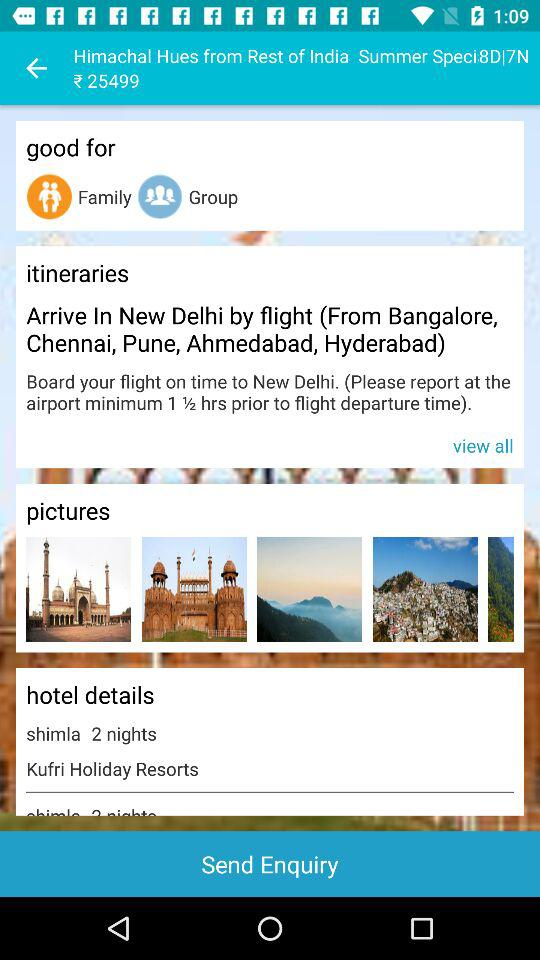What is the location of the hotel? The location of the hotel is Shimla. 